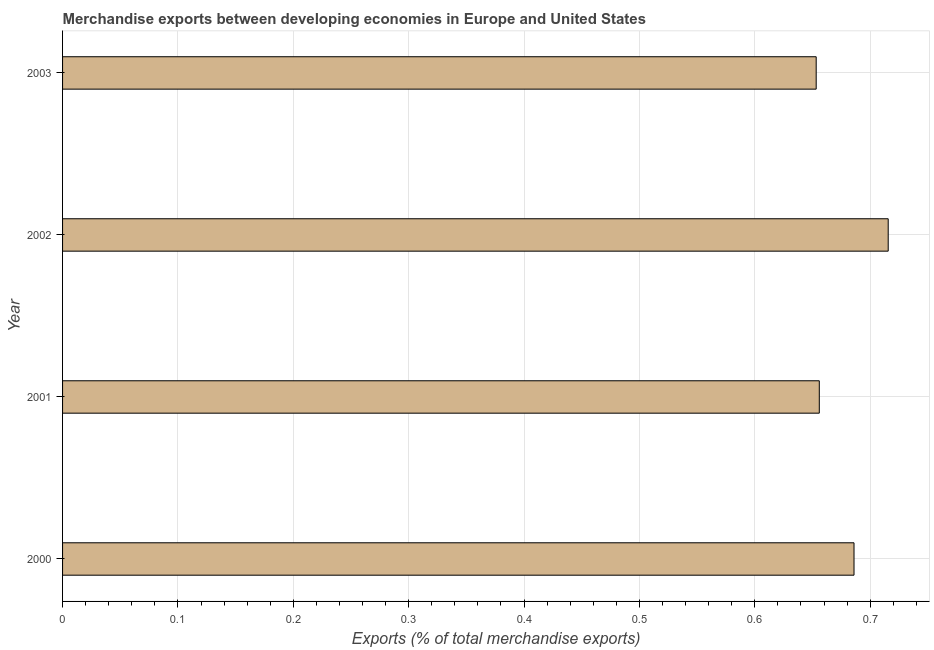Does the graph contain any zero values?
Offer a very short reply. No. Does the graph contain grids?
Give a very brief answer. Yes. What is the title of the graph?
Keep it short and to the point. Merchandise exports between developing economies in Europe and United States. What is the label or title of the X-axis?
Offer a terse response. Exports (% of total merchandise exports). What is the merchandise exports in 2001?
Your answer should be compact. 0.66. Across all years, what is the maximum merchandise exports?
Ensure brevity in your answer.  0.72. Across all years, what is the minimum merchandise exports?
Offer a very short reply. 0.65. In which year was the merchandise exports maximum?
Keep it short and to the point. 2002. In which year was the merchandise exports minimum?
Give a very brief answer. 2003. What is the sum of the merchandise exports?
Your answer should be compact. 2.71. What is the difference between the merchandise exports in 2000 and 2001?
Offer a very short reply. 0.03. What is the average merchandise exports per year?
Keep it short and to the point. 0.68. What is the median merchandise exports?
Your answer should be very brief. 0.67. In how many years, is the merchandise exports greater than 0.38 %?
Your answer should be compact. 4. Do a majority of the years between 2000 and 2001 (inclusive) have merchandise exports greater than 0.26 %?
Your response must be concise. Yes. What is the ratio of the merchandise exports in 2000 to that in 2002?
Keep it short and to the point. 0.96. In how many years, is the merchandise exports greater than the average merchandise exports taken over all years?
Offer a terse response. 2. How many years are there in the graph?
Offer a terse response. 4. What is the difference between two consecutive major ticks on the X-axis?
Your answer should be compact. 0.1. What is the Exports (% of total merchandise exports) of 2000?
Keep it short and to the point. 0.69. What is the Exports (% of total merchandise exports) of 2001?
Keep it short and to the point. 0.66. What is the Exports (% of total merchandise exports) of 2002?
Give a very brief answer. 0.72. What is the Exports (% of total merchandise exports) of 2003?
Keep it short and to the point. 0.65. What is the difference between the Exports (% of total merchandise exports) in 2000 and 2001?
Make the answer very short. 0.03. What is the difference between the Exports (% of total merchandise exports) in 2000 and 2002?
Make the answer very short. -0.03. What is the difference between the Exports (% of total merchandise exports) in 2000 and 2003?
Make the answer very short. 0.03. What is the difference between the Exports (% of total merchandise exports) in 2001 and 2002?
Provide a succinct answer. -0.06. What is the difference between the Exports (% of total merchandise exports) in 2001 and 2003?
Ensure brevity in your answer.  0. What is the difference between the Exports (% of total merchandise exports) in 2002 and 2003?
Your answer should be compact. 0.06. What is the ratio of the Exports (% of total merchandise exports) in 2000 to that in 2001?
Provide a short and direct response. 1.05. What is the ratio of the Exports (% of total merchandise exports) in 2001 to that in 2002?
Give a very brief answer. 0.92. What is the ratio of the Exports (% of total merchandise exports) in 2002 to that in 2003?
Offer a terse response. 1.1. 